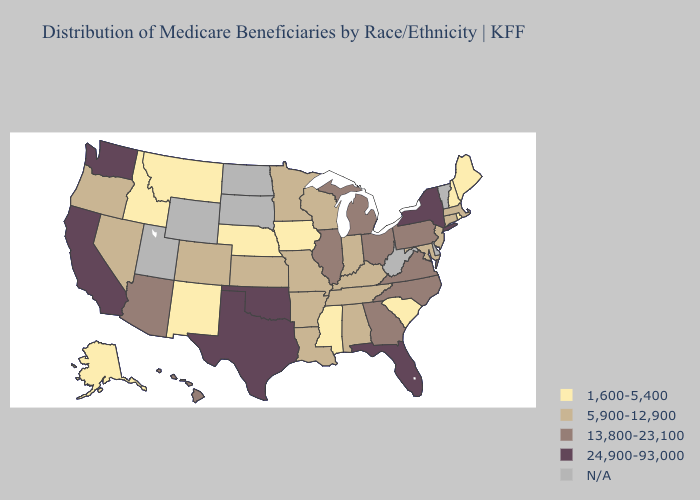What is the highest value in the USA?
Short answer required. 24,900-93,000. Name the states that have a value in the range 13,800-23,100?
Write a very short answer. Arizona, Georgia, Hawaii, Illinois, Michigan, North Carolina, Ohio, Pennsylvania, Virginia. Name the states that have a value in the range 1,600-5,400?
Short answer required. Alaska, Idaho, Iowa, Maine, Mississippi, Montana, Nebraska, New Hampshire, New Mexico, Rhode Island, South Carolina. What is the lowest value in the USA?
Answer briefly. 1,600-5,400. Among the states that border Washington , which have the lowest value?
Short answer required. Idaho. What is the value of Mississippi?
Write a very short answer. 1,600-5,400. Which states have the lowest value in the Northeast?
Concise answer only. Maine, New Hampshire, Rhode Island. Does Wisconsin have the highest value in the MidWest?
Be succinct. No. Which states have the lowest value in the Northeast?
Answer briefly. Maine, New Hampshire, Rhode Island. Name the states that have a value in the range 1,600-5,400?
Concise answer only. Alaska, Idaho, Iowa, Maine, Mississippi, Montana, Nebraska, New Hampshire, New Mexico, Rhode Island, South Carolina. What is the highest value in the West ?
Quick response, please. 24,900-93,000. 